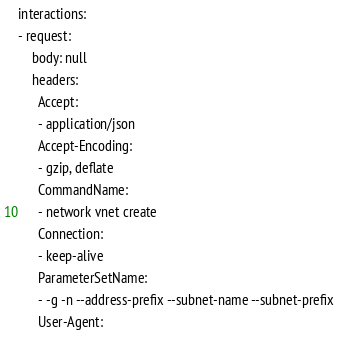<code> <loc_0><loc_0><loc_500><loc_500><_YAML_>interactions:
- request:
    body: null
    headers:
      Accept:
      - application/json
      Accept-Encoding:
      - gzip, deflate
      CommandName:
      - network vnet create
      Connection:
      - keep-alive
      ParameterSetName:
      - -g -n --address-prefix --subnet-name --subnet-prefix
      User-Agent:</code> 